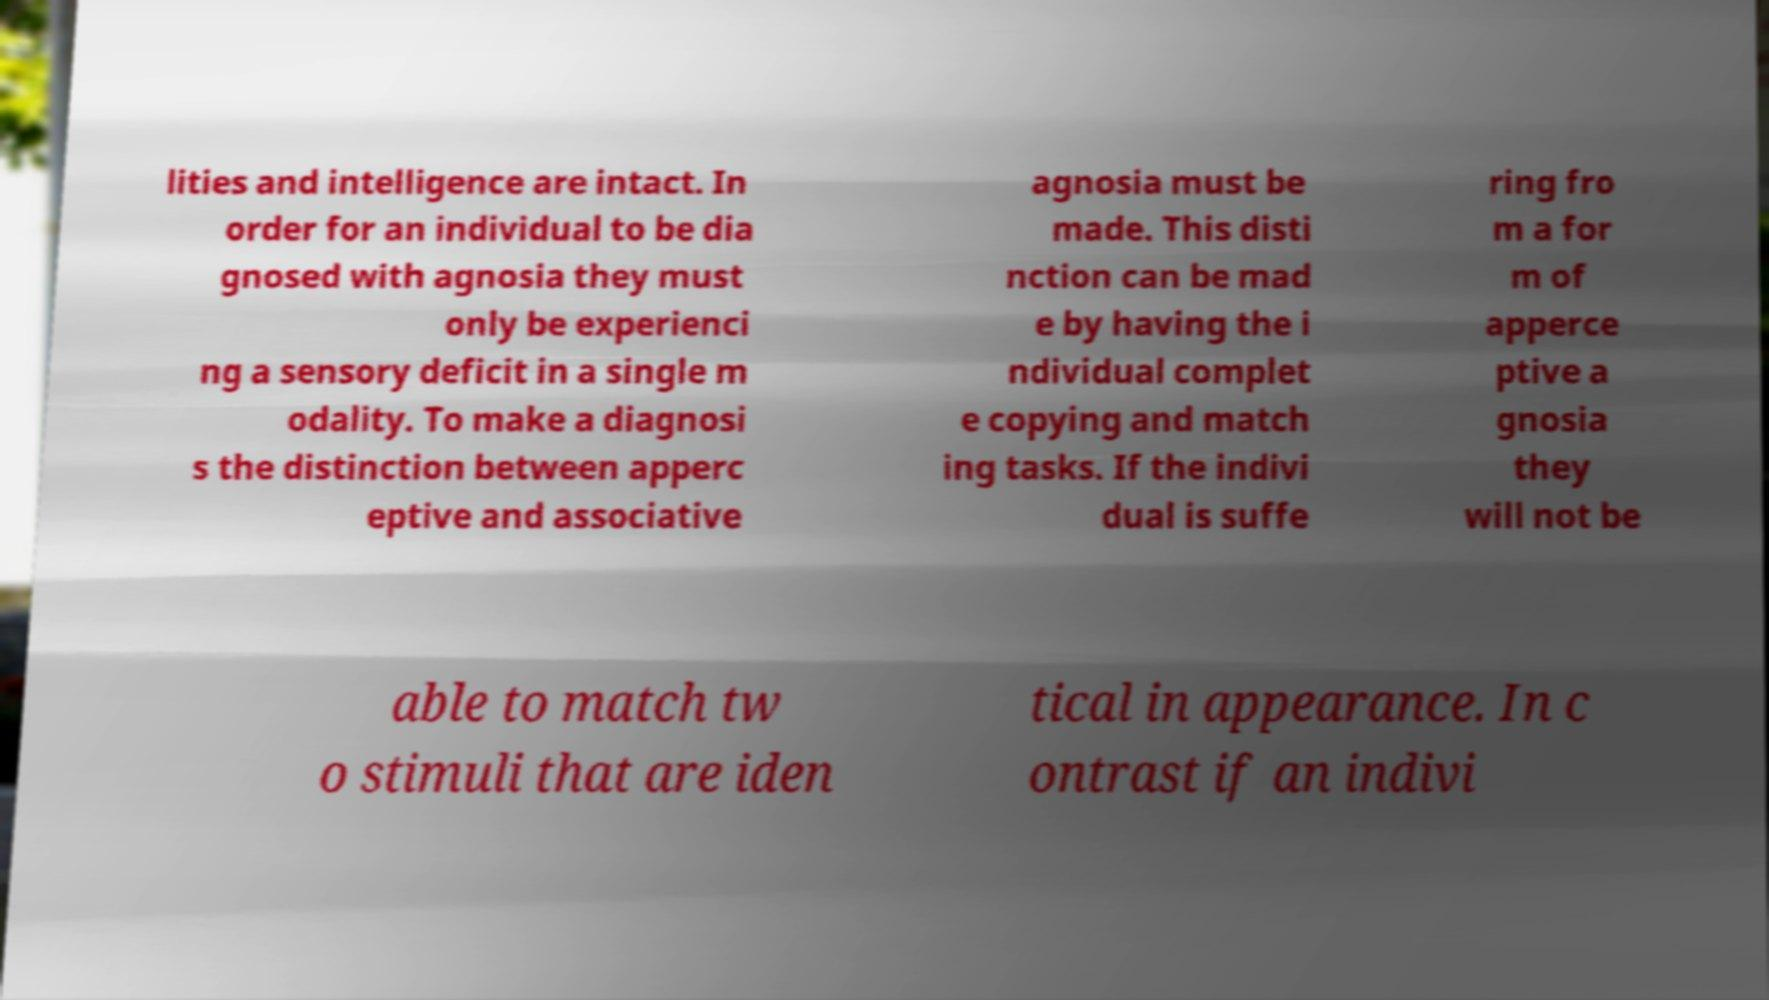What messages or text are displayed in this image? I need them in a readable, typed format. lities and intelligence are intact. In order for an individual to be dia gnosed with agnosia they must only be experienci ng a sensory deficit in a single m odality. To make a diagnosi s the distinction between apperc eptive and associative agnosia must be made. This disti nction can be mad e by having the i ndividual complet e copying and match ing tasks. If the indivi dual is suffe ring fro m a for m of apperce ptive a gnosia they will not be able to match tw o stimuli that are iden tical in appearance. In c ontrast if an indivi 